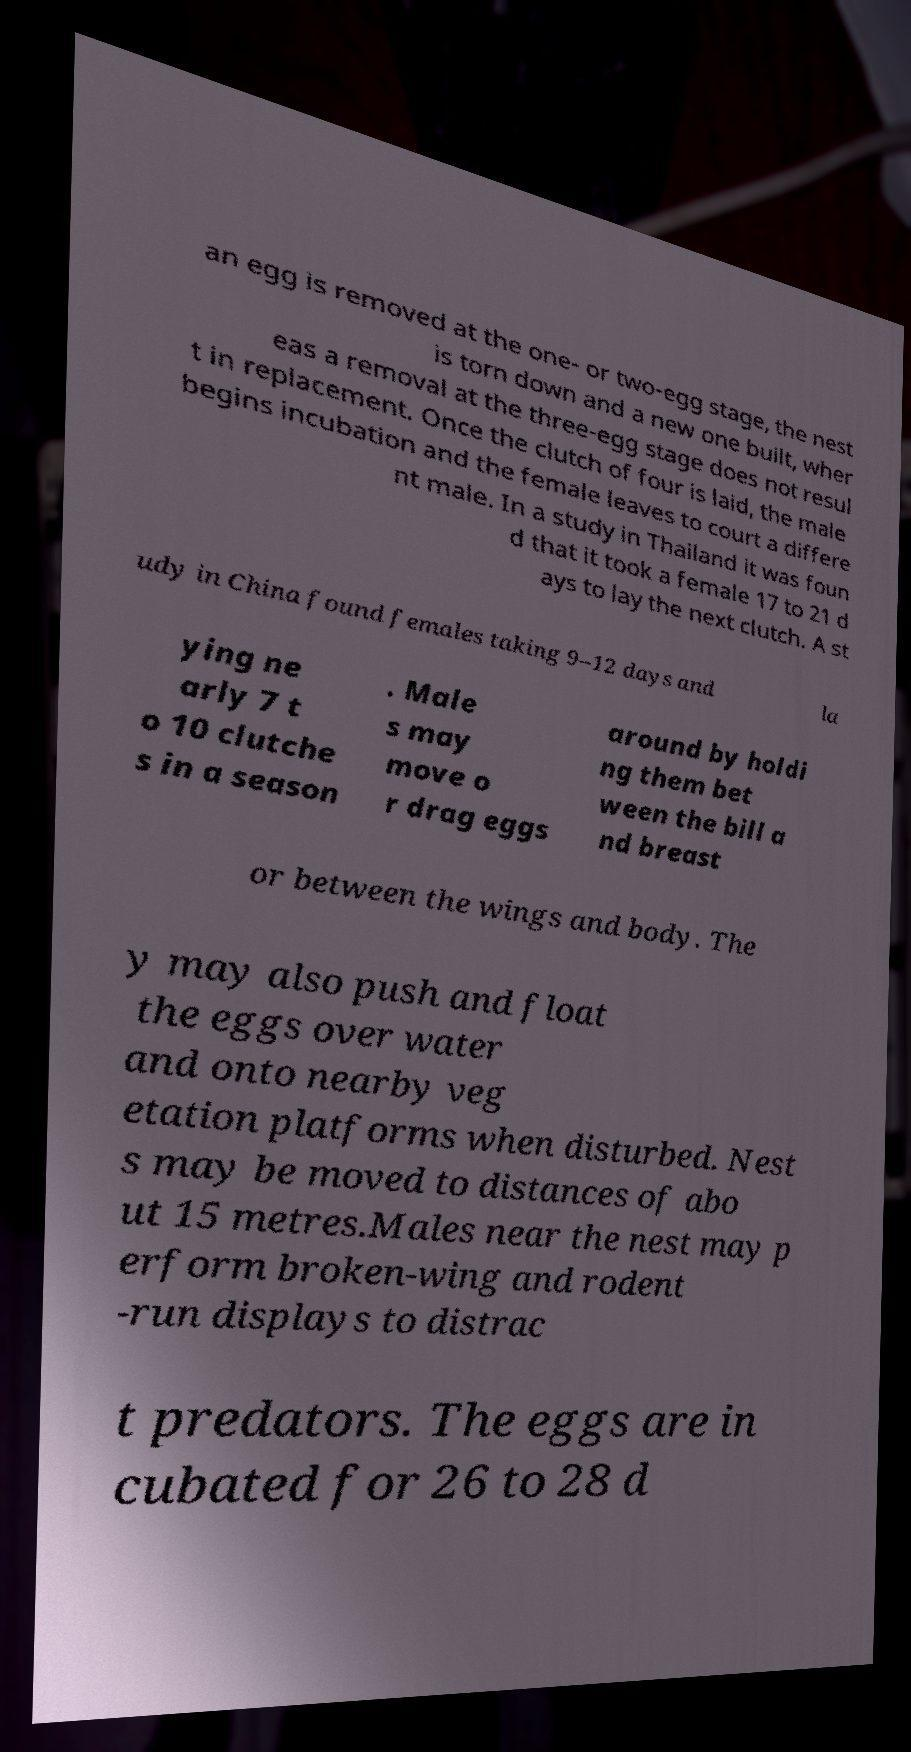Can you read and provide the text displayed in the image?This photo seems to have some interesting text. Can you extract and type it out for me? an egg is removed at the one- or two-egg stage, the nest is torn down and a new one built, wher eas a removal at the three-egg stage does not resul t in replacement. Once the clutch of four is laid, the male begins incubation and the female leaves to court a differe nt male. In a study in Thailand it was foun d that it took a female 17 to 21 d ays to lay the next clutch. A st udy in China found females taking 9–12 days and la ying ne arly 7 t o 10 clutche s in a season . Male s may move o r drag eggs around by holdi ng them bet ween the bill a nd breast or between the wings and body. The y may also push and float the eggs over water and onto nearby veg etation platforms when disturbed. Nest s may be moved to distances of abo ut 15 metres.Males near the nest may p erform broken-wing and rodent -run displays to distrac t predators. The eggs are in cubated for 26 to 28 d 